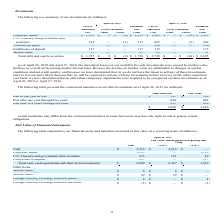From Netapp's financial document, What type of cost and value information does the table provide about the contractual maturities of our debt investments as of April 26, 2019? The document shows two values: Amortized Cost and Fair Value. From the document: "s of April 26, 2019 (in millions): Amortized Cost Fair Value t investments as of April 26, 2019 (in millions): Amortized Cost Fair Value..." Also, What was the amortized cost Due after one year through five years? According to the financial document, 644 (in millions). The relevant text states: "Due after one year through five years 644 642..." Also, What was the total fair value debt? According to the financial document, 1,683 (in millions). The relevant text states: "$ 1,690 $ 1,683..." Also, can you calculate: What was the amortized cost that was due in one year or less as a ratio of the fair value for the same period? Based on the calculation: 591/589, the result is 100.34 (percentage). This is based on the information: "Due in one year or less $ 591 $ 589 Due in one year or less $ 591 $ 589..." The key data points involved are: 589, 591. Also, can you calculate: What was the difference between the amortized cost and fair value that was due after five years through ten years? Based on the calculation: 455-452, the result is 3 (in millions). This is based on the information: "Due after five years through ten years 455 452 Due after five years through ten years 455 452..." The key data points involved are: 452, 455. Also, can you calculate: What was the difference in the total amortized cost and fair value? Based on the calculation: 1,690-1,683, the result is 7 (in millions). This is based on the information: "$ 1,690 $ 1,683 $ 1,690 $ 1,683..." The key data points involved are: 1,683, 1,690. 